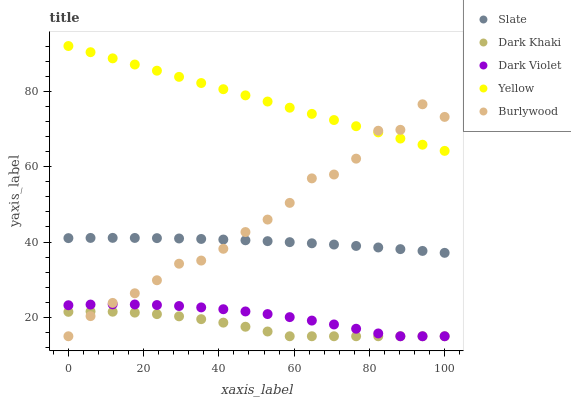Does Dark Khaki have the minimum area under the curve?
Answer yes or no. Yes. Does Yellow have the maximum area under the curve?
Answer yes or no. Yes. Does Burlywood have the minimum area under the curve?
Answer yes or no. No. Does Burlywood have the maximum area under the curve?
Answer yes or no. No. Is Yellow the smoothest?
Answer yes or no. Yes. Is Burlywood the roughest?
Answer yes or no. Yes. Is Slate the smoothest?
Answer yes or no. No. Is Slate the roughest?
Answer yes or no. No. Does Dark Khaki have the lowest value?
Answer yes or no. Yes. Does Slate have the lowest value?
Answer yes or no. No. Does Yellow have the highest value?
Answer yes or no. Yes. Does Burlywood have the highest value?
Answer yes or no. No. Is Dark Violet less than Slate?
Answer yes or no. Yes. Is Slate greater than Dark Khaki?
Answer yes or no. Yes. Does Yellow intersect Burlywood?
Answer yes or no. Yes. Is Yellow less than Burlywood?
Answer yes or no. No. Is Yellow greater than Burlywood?
Answer yes or no. No. Does Dark Violet intersect Slate?
Answer yes or no. No. 